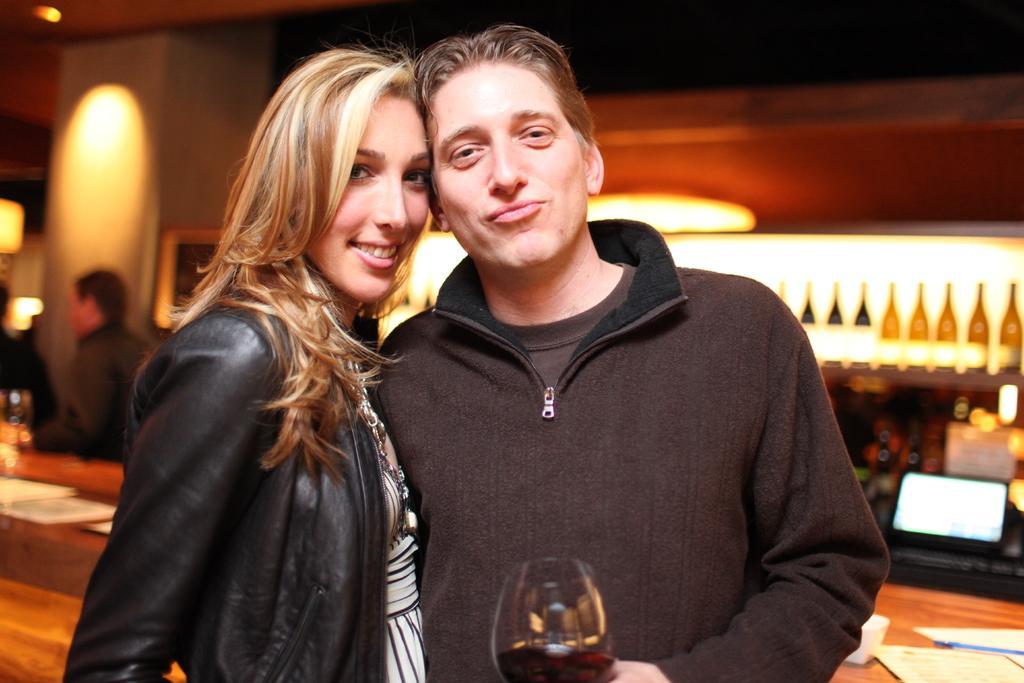Please provide a concise description of this image. In this image the man and woman are standing. The man is holding a glass and woman is smiling. At the back side i can see a wine bottles and a laptop. On the table there is a paper. 